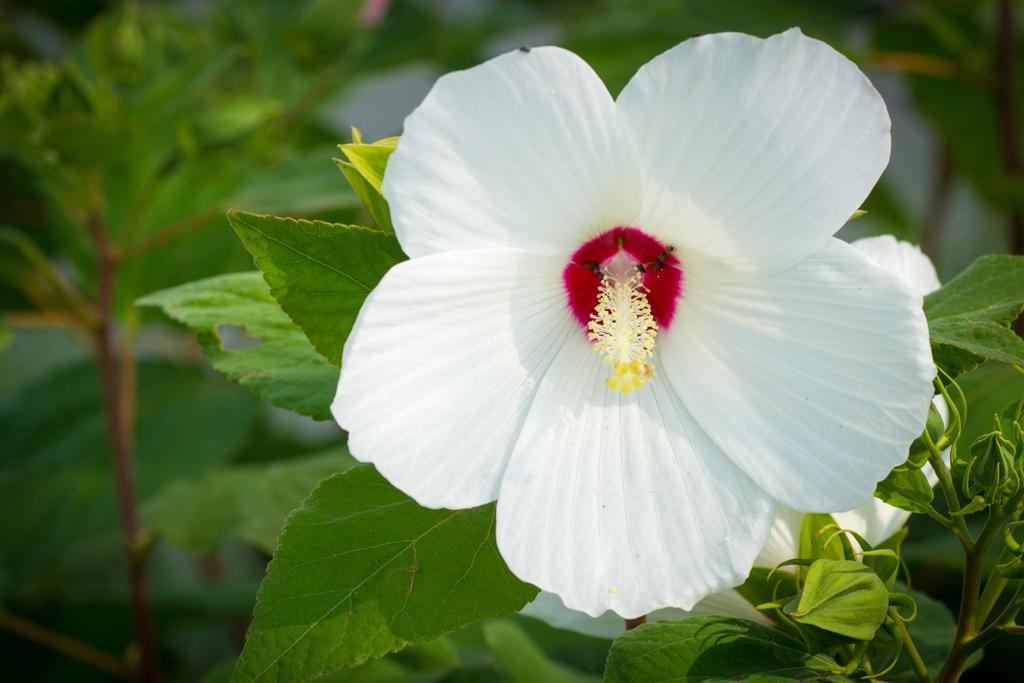What is the main subject of the image? There is a flower in the image. What else can be seen in the image besides the flower? There are leaves in the image. Can you describe the background of the image? The background of the image is blurred. What type of liquid is being used by the fireman in the image? There is no fireman or liquid present in the image; it features a flower and leaves with a blurred background. 